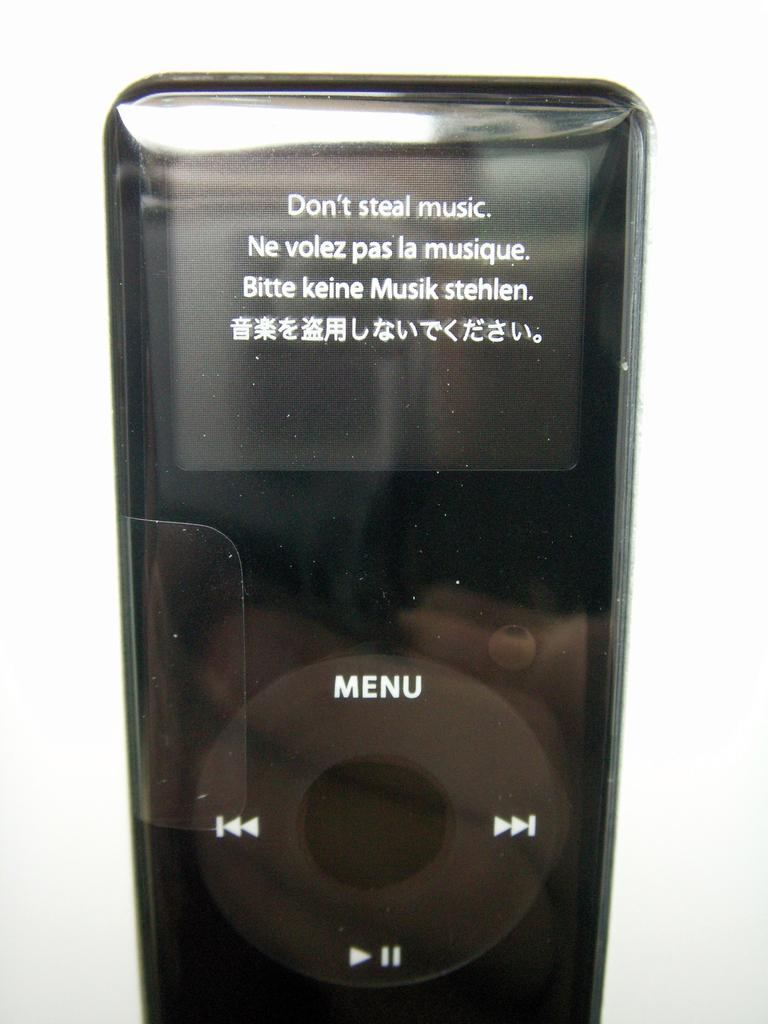<image>
Give a short and clear explanation of the subsequent image. An iPod says Don't steal music on its display. 